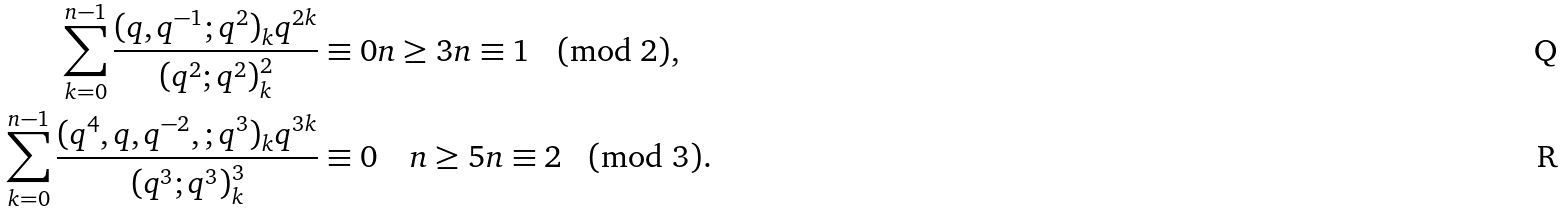<formula> <loc_0><loc_0><loc_500><loc_500>\sum _ { k = 0 } ^ { n - 1 } \frac { ( q , q ^ { - 1 } ; q ^ { 2 } ) _ { k } q ^ { 2 k } } { ( q ^ { 2 } ; q ^ { 2 } ) _ { k } ^ { 2 } } & \equiv 0 n \geq 3 n \equiv 1 \pmod { 2 } , \\ \sum _ { k = 0 } ^ { n - 1 } \frac { ( q ^ { 4 } , q , q ^ { - 2 } , ; q ^ { 3 } ) _ { k } q ^ { 3 k } } { ( q ^ { 3 } ; q ^ { 3 } ) _ { k } ^ { 3 } } & \equiv 0 \quad n \geq 5 n \equiv 2 \pmod { 3 } .</formula> 